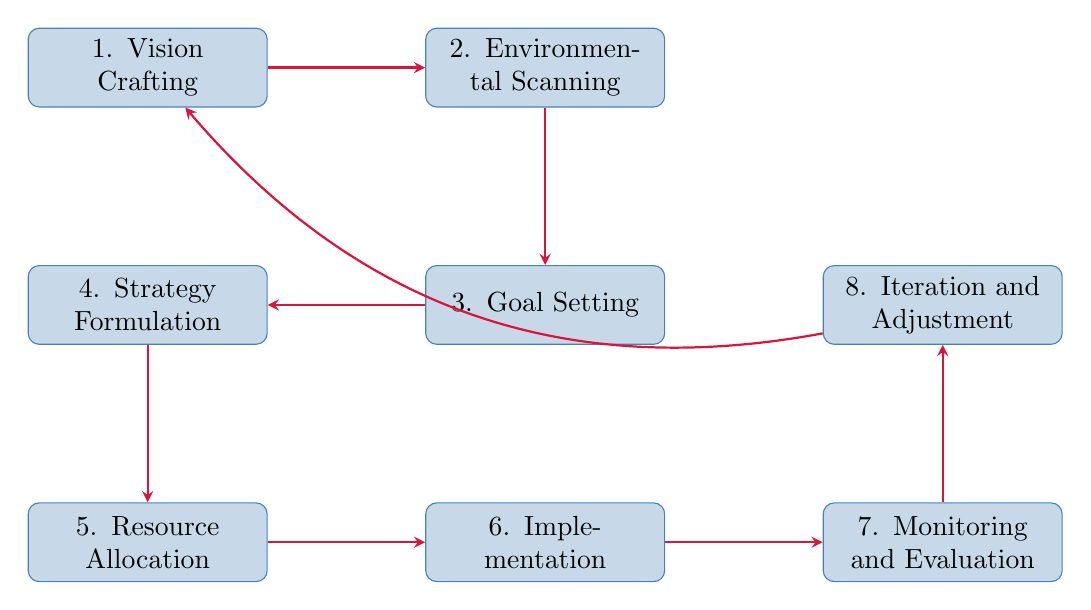What is the first stage in the strategic planning process? The diagram indicates that the first stage is "Vision Crafting," which is the starting point of the flow chart.
Answer: Vision Crafting How many stages are there in the strategic planning process? By counting all the nodes in the diagram, there are a total of eight distinct stages represented.
Answer: Eight Which stage directly follows "Environmental Scanning"? The diagram shows that the stage that follows "Environmental Scanning" is "Goal Setting," indicating a sequential flow.
Answer: Goal Setting What comes after "Implementation"? According to the diagram, "Monitoring and Evaluation" directly follows the "Implementation" stage, suggesting it is the next step in the process.
Answer: Monitoring and Evaluation What is the last stage that connects back to the first stage? The diagram illustrates that "Iteration and Adjustment" is the last stage, which loops back to the first stage, indicating a cyclical process.
Answer: Iteration and Adjustment If the resources required are not allocated, which stage would be affected directly following this? The flowchart indicates that "Implementation" is the next step after "Resource Allocation," so if resources are not allocated, "Implementation" will be directly affected.
Answer: Implementation Which two stages are linked by a direct pathway in the reverse direction? The diagram shows a direct pathway going backwards from "Iteration and Adjustment" to "Vision Crafting," indicating a feedback loop between these two stages.
Answer: Vision Crafting and Iteration and Adjustment What is the key analysis method mentioned in the second stage? The second stage, "Environmental Scanning," mentions SWOT Analysis as the key method for analyzing internal and external environments.
Answer: SWOT Analysis 